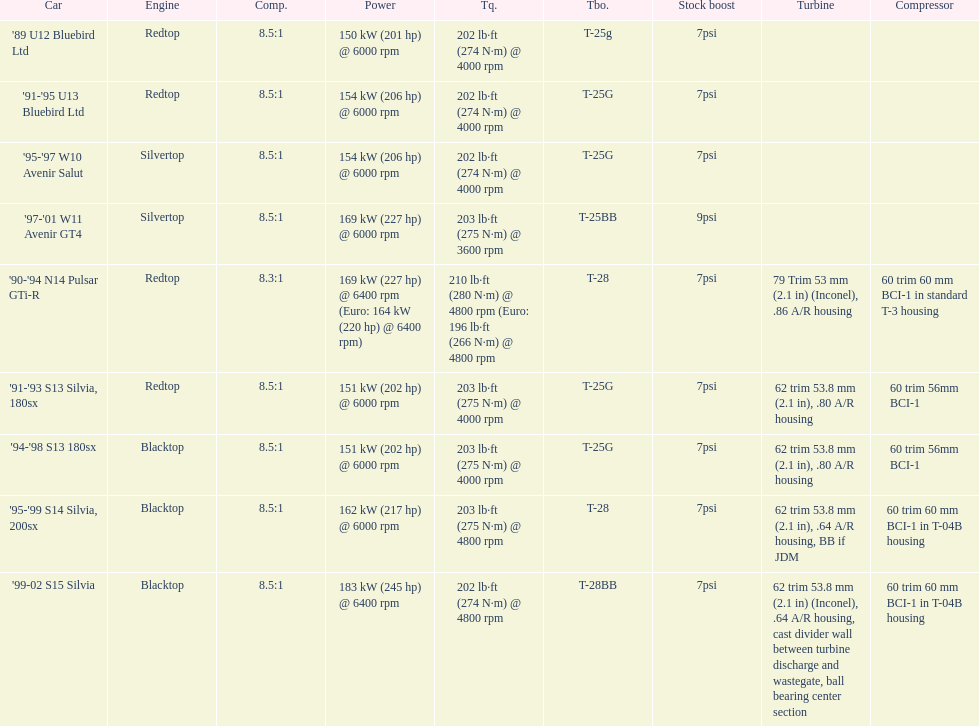What is his/her compression for the 90-94 n14 pulsar gti-r? 8.3:1. 